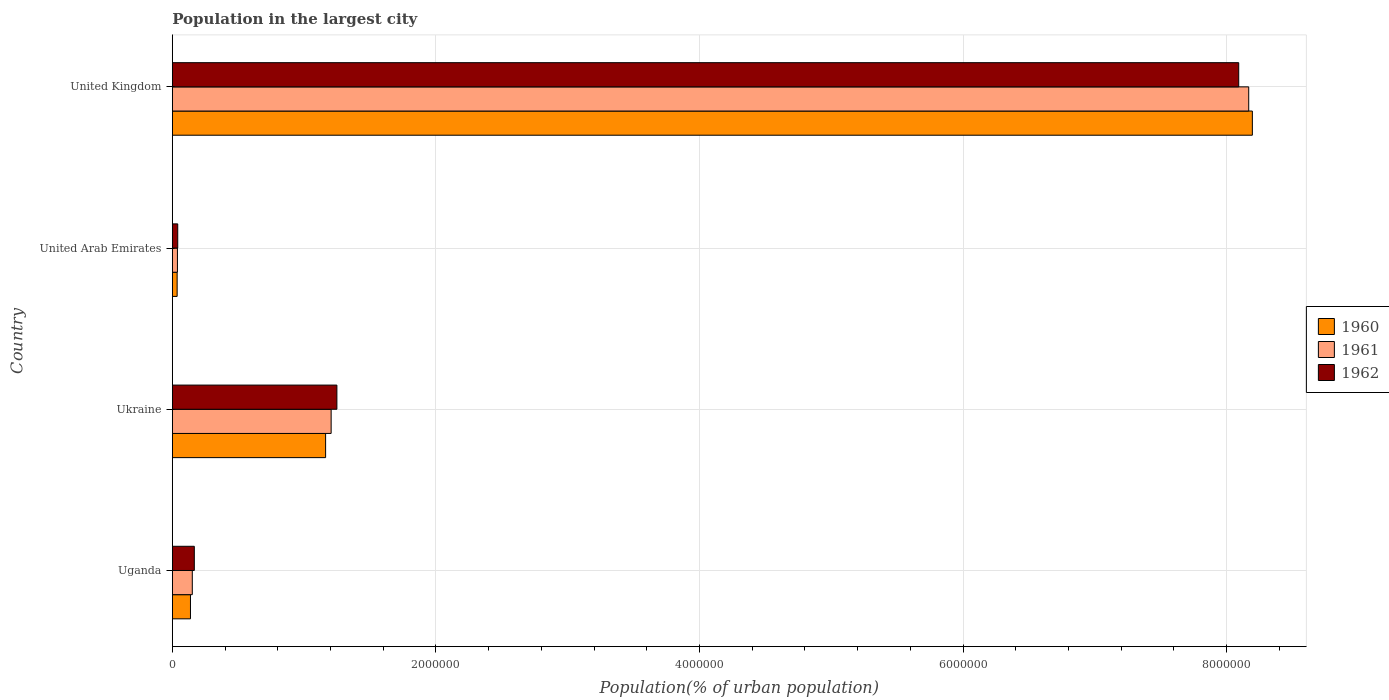How many groups of bars are there?
Give a very brief answer. 4. Are the number of bars on each tick of the Y-axis equal?
Make the answer very short. Yes. How many bars are there on the 3rd tick from the top?
Your response must be concise. 3. What is the label of the 3rd group of bars from the top?
Your response must be concise. Ukraine. What is the population in the largest city in 1960 in Uganda?
Your answer should be very brief. 1.37e+05. Across all countries, what is the maximum population in the largest city in 1960?
Offer a terse response. 8.20e+06. Across all countries, what is the minimum population in the largest city in 1962?
Make the answer very short. 4.09e+04. In which country was the population in the largest city in 1960 maximum?
Offer a terse response. United Kingdom. In which country was the population in the largest city in 1962 minimum?
Offer a very short reply. United Arab Emirates. What is the total population in the largest city in 1960 in the graph?
Ensure brevity in your answer.  9.53e+06. What is the difference between the population in the largest city in 1960 in Uganda and that in United Arab Emirates?
Offer a very short reply. 1.01e+05. What is the difference between the population in the largest city in 1960 in United Kingdom and the population in the largest city in 1962 in United Arab Emirates?
Provide a succinct answer. 8.15e+06. What is the average population in the largest city in 1961 per country?
Provide a succinct answer. 2.39e+06. What is the difference between the population in the largest city in 1962 and population in the largest city in 1960 in United Kingdom?
Your response must be concise. -1.04e+05. What is the ratio of the population in the largest city in 1962 in Ukraine to that in United Kingdom?
Offer a very short reply. 0.15. Is the difference between the population in the largest city in 1962 in Ukraine and United Kingdom greater than the difference between the population in the largest city in 1960 in Ukraine and United Kingdom?
Give a very brief answer. Yes. What is the difference between the highest and the second highest population in the largest city in 1960?
Provide a short and direct response. 7.03e+06. What is the difference between the highest and the lowest population in the largest city in 1960?
Provide a short and direct response. 8.16e+06. Is the sum of the population in the largest city in 1962 in Uganda and Ukraine greater than the maximum population in the largest city in 1961 across all countries?
Your answer should be compact. No. What does the 3rd bar from the bottom in United Kingdom represents?
Your response must be concise. 1962. Is it the case that in every country, the sum of the population in the largest city in 1962 and population in the largest city in 1960 is greater than the population in the largest city in 1961?
Your answer should be very brief. Yes. How many bars are there?
Ensure brevity in your answer.  12. What is the difference between two consecutive major ticks on the X-axis?
Provide a succinct answer. 2.00e+06. Are the values on the major ticks of X-axis written in scientific E-notation?
Your response must be concise. No. Does the graph contain any zero values?
Ensure brevity in your answer.  No. Does the graph contain grids?
Offer a terse response. Yes. What is the title of the graph?
Provide a short and direct response. Population in the largest city. What is the label or title of the X-axis?
Ensure brevity in your answer.  Population(% of urban population). What is the Population(% of urban population) in 1960 in Uganda?
Your answer should be compact. 1.37e+05. What is the Population(% of urban population) in 1961 in Uganda?
Keep it short and to the point. 1.51e+05. What is the Population(% of urban population) of 1962 in Uganda?
Provide a short and direct response. 1.67e+05. What is the Population(% of urban population) of 1960 in Ukraine?
Offer a terse response. 1.16e+06. What is the Population(% of urban population) of 1961 in Ukraine?
Offer a very short reply. 1.21e+06. What is the Population(% of urban population) in 1962 in Ukraine?
Provide a succinct answer. 1.25e+06. What is the Population(% of urban population) of 1960 in United Arab Emirates?
Keep it short and to the point. 3.63e+04. What is the Population(% of urban population) of 1961 in United Arab Emirates?
Your response must be concise. 3.85e+04. What is the Population(% of urban population) of 1962 in United Arab Emirates?
Provide a succinct answer. 4.09e+04. What is the Population(% of urban population) in 1960 in United Kingdom?
Your answer should be compact. 8.20e+06. What is the Population(% of urban population) in 1961 in United Kingdom?
Offer a terse response. 8.17e+06. What is the Population(% of urban population) of 1962 in United Kingdom?
Your response must be concise. 8.09e+06. Across all countries, what is the maximum Population(% of urban population) in 1960?
Provide a succinct answer. 8.20e+06. Across all countries, what is the maximum Population(% of urban population) of 1961?
Your answer should be compact. 8.17e+06. Across all countries, what is the maximum Population(% of urban population) in 1962?
Your answer should be compact. 8.09e+06. Across all countries, what is the minimum Population(% of urban population) in 1960?
Keep it short and to the point. 3.63e+04. Across all countries, what is the minimum Population(% of urban population) in 1961?
Your response must be concise. 3.85e+04. Across all countries, what is the minimum Population(% of urban population) in 1962?
Your response must be concise. 4.09e+04. What is the total Population(% of urban population) in 1960 in the graph?
Offer a very short reply. 9.53e+06. What is the total Population(% of urban population) in 1961 in the graph?
Your answer should be compact. 9.56e+06. What is the total Population(% of urban population) of 1962 in the graph?
Keep it short and to the point. 9.55e+06. What is the difference between the Population(% of urban population) of 1960 in Uganda and that in Ukraine?
Ensure brevity in your answer.  -1.03e+06. What is the difference between the Population(% of urban population) of 1961 in Uganda and that in Ukraine?
Your answer should be very brief. -1.05e+06. What is the difference between the Population(% of urban population) in 1962 in Uganda and that in Ukraine?
Make the answer very short. -1.08e+06. What is the difference between the Population(% of urban population) of 1960 in Uganda and that in United Arab Emirates?
Your answer should be very brief. 1.01e+05. What is the difference between the Population(% of urban population) in 1961 in Uganda and that in United Arab Emirates?
Provide a succinct answer. 1.13e+05. What is the difference between the Population(% of urban population) of 1962 in Uganda and that in United Arab Emirates?
Your answer should be compact. 1.26e+05. What is the difference between the Population(% of urban population) of 1960 in Uganda and that in United Kingdom?
Offer a terse response. -8.06e+06. What is the difference between the Population(% of urban population) of 1961 in Uganda and that in United Kingdom?
Your response must be concise. -8.02e+06. What is the difference between the Population(% of urban population) of 1962 in Uganda and that in United Kingdom?
Provide a succinct answer. -7.93e+06. What is the difference between the Population(% of urban population) in 1960 in Ukraine and that in United Arab Emirates?
Your answer should be very brief. 1.13e+06. What is the difference between the Population(% of urban population) in 1961 in Ukraine and that in United Arab Emirates?
Keep it short and to the point. 1.17e+06. What is the difference between the Population(% of urban population) of 1962 in Ukraine and that in United Arab Emirates?
Your response must be concise. 1.21e+06. What is the difference between the Population(% of urban population) of 1960 in Ukraine and that in United Kingdom?
Provide a short and direct response. -7.03e+06. What is the difference between the Population(% of urban population) in 1961 in Ukraine and that in United Kingdom?
Make the answer very short. -6.96e+06. What is the difference between the Population(% of urban population) in 1962 in Ukraine and that in United Kingdom?
Provide a succinct answer. -6.84e+06. What is the difference between the Population(% of urban population) of 1960 in United Arab Emirates and that in United Kingdom?
Ensure brevity in your answer.  -8.16e+06. What is the difference between the Population(% of urban population) of 1961 in United Arab Emirates and that in United Kingdom?
Your answer should be very brief. -8.13e+06. What is the difference between the Population(% of urban population) of 1962 in United Arab Emirates and that in United Kingdom?
Make the answer very short. -8.05e+06. What is the difference between the Population(% of urban population) of 1960 in Uganda and the Population(% of urban population) of 1961 in Ukraine?
Offer a very short reply. -1.07e+06. What is the difference between the Population(% of urban population) in 1960 in Uganda and the Population(% of urban population) in 1962 in Ukraine?
Provide a succinct answer. -1.11e+06. What is the difference between the Population(% of urban population) of 1961 in Uganda and the Population(% of urban population) of 1962 in Ukraine?
Offer a very short reply. -1.10e+06. What is the difference between the Population(% of urban population) in 1960 in Uganda and the Population(% of urban population) in 1961 in United Arab Emirates?
Provide a short and direct response. 9.89e+04. What is the difference between the Population(% of urban population) in 1960 in Uganda and the Population(% of urban population) in 1962 in United Arab Emirates?
Keep it short and to the point. 9.66e+04. What is the difference between the Population(% of urban population) in 1961 in Uganda and the Population(% of urban population) in 1962 in United Arab Emirates?
Offer a terse response. 1.10e+05. What is the difference between the Population(% of urban population) in 1960 in Uganda and the Population(% of urban population) in 1961 in United Kingdom?
Offer a very short reply. -8.03e+06. What is the difference between the Population(% of urban population) of 1960 in Uganda and the Population(% of urban population) of 1962 in United Kingdom?
Your answer should be compact. -7.95e+06. What is the difference between the Population(% of urban population) in 1961 in Uganda and the Population(% of urban population) in 1962 in United Kingdom?
Provide a short and direct response. -7.94e+06. What is the difference between the Population(% of urban population) of 1960 in Ukraine and the Population(% of urban population) of 1961 in United Arab Emirates?
Keep it short and to the point. 1.12e+06. What is the difference between the Population(% of urban population) in 1960 in Ukraine and the Population(% of urban population) in 1962 in United Arab Emirates?
Ensure brevity in your answer.  1.12e+06. What is the difference between the Population(% of urban population) of 1961 in Ukraine and the Population(% of urban population) of 1962 in United Arab Emirates?
Make the answer very short. 1.16e+06. What is the difference between the Population(% of urban population) of 1960 in Ukraine and the Population(% of urban population) of 1961 in United Kingdom?
Your response must be concise. -7.01e+06. What is the difference between the Population(% of urban population) in 1960 in Ukraine and the Population(% of urban population) in 1962 in United Kingdom?
Keep it short and to the point. -6.93e+06. What is the difference between the Population(% of urban population) in 1961 in Ukraine and the Population(% of urban population) in 1962 in United Kingdom?
Keep it short and to the point. -6.89e+06. What is the difference between the Population(% of urban population) in 1960 in United Arab Emirates and the Population(% of urban population) in 1961 in United Kingdom?
Provide a short and direct response. -8.13e+06. What is the difference between the Population(% of urban population) in 1960 in United Arab Emirates and the Population(% of urban population) in 1962 in United Kingdom?
Provide a short and direct response. -8.06e+06. What is the difference between the Population(% of urban population) in 1961 in United Arab Emirates and the Population(% of urban population) in 1962 in United Kingdom?
Give a very brief answer. -8.05e+06. What is the average Population(% of urban population) in 1960 per country?
Offer a terse response. 2.38e+06. What is the average Population(% of urban population) of 1961 per country?
Ensure brevity in your answer.  2.39e+06. What is the average Population(% of urban population) of 1962 per country?
Ensure brevity in your answer.  2.39e+06. What is the difference between the Population(% of urban population) of 1960 and Population(% of urban population) of 1961 in Uganda?
Give a very brief answer. -1.39e+04. What is the difference between the Population(% of urban population) in 1960 and Population(% of urban population) in 1962 in Uganda?
Your answer should be very brief. -2.91e+04. What is the difference between the Population(% of urban population) in 1961 and Population(% of urban population) in 1962 in Uganda?
Provide a short and direct response. -1.53e+04. What is the difference between the Population(% of urban population) in 1960 and Population(% of urban population) in 1961 in Ukraine?
Your answer should be very brief. -4.20e+04. What is the difference between the Population(% of urban population) of 1960 and Population(% of urban population) of 1962 in Ukraine?
Ensure brevity in your answer.  -8.55e+04. What is the difference between the Population(% of urban population) of 1961 and Population(% of urban population) of 1962 in Ukraine?
Provide a short and direct response. -4.36e+04. What is the difference between the Population(% of urban population) in 1960 and Population(% of urban population) in 1961 in United Arab Emirates?
Make the answer very short. -2229. What is the difference between the Population(% of urban population) in 1960 and Population(% of urban population) in 1962 in United Arab Emirates?
Give a very brief answer. -4598. What is the difference between the Population(% of urban population) in 1961 and Population(% of urban population) in 1962 in United Arab Emirates?
Your answer should be compact. -2369. What is the difference between the Population(% of urban population) in 1960 and Population(% of urban population) in 1961 in United Kingdom?
Your response must be concise. 2.77e+04. What is the difference between the Population(% of urban population) of 1960 and Population(% of urban population) of 1962 in United Kingdom?
Offer a terse response. 1.04e+05. What is the difference between the Population(% of urban population) in 1961 and Population(% of urban population) in 1962 in United Kingdom?
Provide a succinct answer. 7.60e+04. What is the ratio of the Population(% of urban population) in 1960 in Uganda to that in Ukraine?
Provide a succinct answer. 0.12. What is the ratio of the Population(% of urban population) in 1961 in Uganda to that in Ukraine?
Your answer should be compact. 0.13. What is the ratio of the Population(% of urban population) of 1962 in Uganda to that in Ukraine?
Offer a very short reply. 0.13. What is the ratio of the Population(% of urban population) in 1960 in Uganda to that in United Arab Emirates?
Give a very brief answer. 3.79. What is the ratio of the Population(% of urban population) in 1961 in Uganda to that in United Arab Emirates?
Offer a very short reply. 3.93. What is the ratio of the Population(% of urban population) of 1962 in Uganda to that in United Arab Emirates?
Your answer should be very brief. 4.07. What is the ratio of the Population(% of urban population) of 1960 in Uganda to that in United Kingdom?
Provide a succinct answer. 0.02. What is the ratio of the Population(% of urban population) in 1961 in Uganda to that in United Kingdom?
Your answer should be very brief. 0.02. What is the ratio of the Population(% of urban population) in 1962 in Uganda to that in United Kingdom?
Make the answer very short. 0.02. What is the ratio of the Population(% of urban population) in 1960 in Ukraine to that in United Arab Emirates?
Keep it short and to the point. 32.03. What is the ratio of the Population(% of urban population) in 1961 in Ukraine to that in United Arab Emirates?
Offer a very short reply. 31.26. What is the ratio of the Population(% of urban population) in 1962 in Ukraine to that in United Arab Emirates?
Offer a very short reply. 30.52. What is the ratio of the Population(% of urban population) of 1960 in Ukraine to that in United Kingdom?
Your answer should be compact. 0.14. What is the ratio of the Population(% of urban population) in 1961 in Ukraine to that in United Kingdom?
Offer a terse response. 0.15. What is the ratio of the Population(% of urban population) in 1962 in Ukraine to that in United Kingdom?
Your answer should be compact. 0.15. What is the ratio of the Population(% of urban population) of 1960 in United Arab Emirates to that in United Kingdom?
Make the answer very short. 0. What is the ratio of the Population(% of urban population) in 1961 in United Arab Emirates to that in United Kingdom?
Keep it short and to the point. 0. What is the ratio of the Population(% of urban population) in 1962 in United Arab Emirates to that in United Kingdom?
Offer a terse response. 0.01. What is the difference between the highest and the second highest Population(% of urban population) in 1960?
Provide a short and direct response. 7.03e+06. What is the difference between the highest and the second highest Population(% of urban population) of 1961?
Keep it short and to the point. 6.96e+06. What is the difference between the highest and the second highest Population(% of urban population) of 1962?
Keep it short and to the point. 6.84e+06. What is the difference between the highest and the lowest Population(% of urban population) of 1960?
Keep it short and to the point. 8.16e+06. What is the difference between the highest and the lowest Population(% of urban population) in 1961?
Offer a very short reply. 8.13e+06. What is the difference between the highest and the lowest Population(% of urban population) in 1962?
Your answer should be very brief. 8.05e+06. 